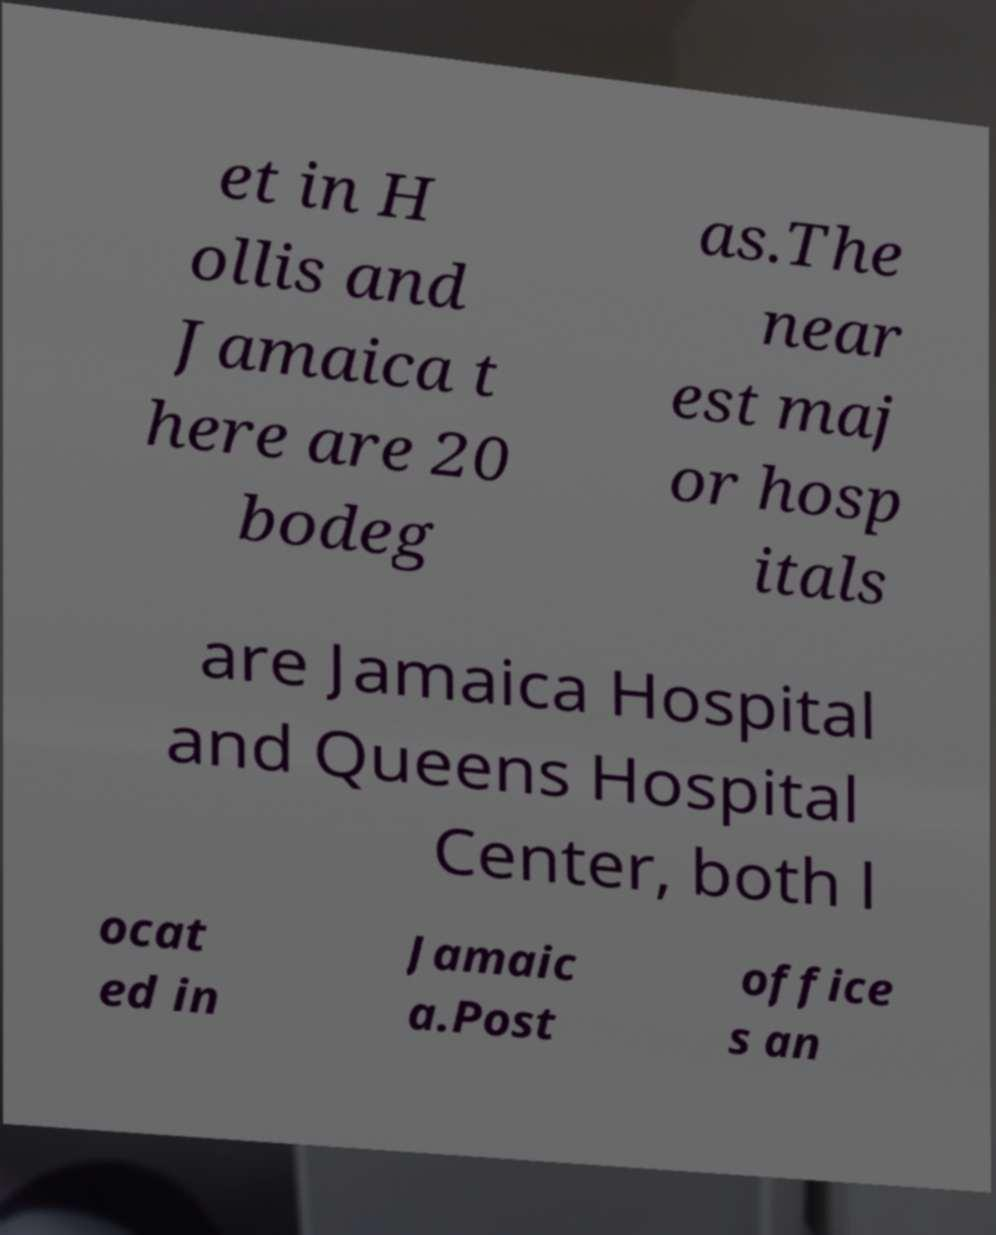Could you extract and type out the text from this image? et in H ollis and Jamaica t here are 20 bodeg as.The near est maj or hosp itals are Jamaica Hospital and Queens Hospital Center, both l ocat ed in Jamaic a.Post office s an 